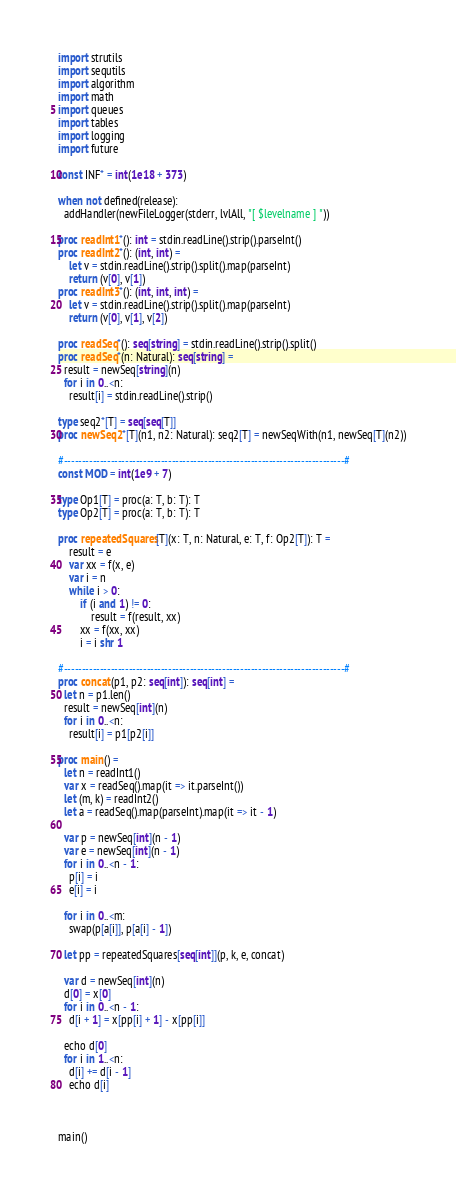Convert code to text. <code><loc_0><loc_0><loc_500><loc_500><_Nim_>import strutils
import sequtils
import algorithm
import math
import queues
import tables
import logging
import future

const INF* = int(1e18 + 373)

when not defined(release):
  addHandler(newFileLogger(stderr, lvlAll, "[ $levelname ] "))

proc readInt1*(): int = stdin.readLine().strip().parseInt()
proc readInt2*(): (int, int) =
    let v = stdin.readLine().strip().split().map(parseInt)
    return (v[0], v[1])
proc readInt3*(): (int, int, int) =
    let v = stdin.readLine().strip().split().map(parseInt)
    return (v[0], v[1], v[2])

proc readSeq*(): seq[string] = stdin.readLine().strip().split()
proc readSeq*(n: Natural): seq[string] =
  result = newSeq[string](n)
  for i in 0..<n:
    result[i] = stdin.readLine().strip()

type seq2*[T] = seq[seq[T]]
proc newSeq2*[T](n1, n2: Natural): seq2[T] = newSeqWith(n1, newSeq[T](n2))

#------------------------------------------------------------------------------#
const MOD = int(1e9 + 7)

type Op1[T] = proc(a: T, b: T): T
type Op2[T] = proc(a: T, b: T): T

proc repeatedSquares[T](x: T, n: Natural, e: T, f: Op2[T]): T =
    result = e
    var xx = f(x, e)
    var i = n
    while i > 0:
        if (i and 1) != 0:
            result = f(result, xx)
        xx = f(xx, xx)
        i = i shr 1

#------------------------------------------------------------------------------#
proc concat(p1, p2: seq[int]): seq[int] =
  let n = p1.len()
  result = newSeq[int](n)
  for i in 0..<n:
    result[i] = p1[p2[i]]

proc main() =
  let n = readInt1()
  var x = readSeq().map(it => it.parseInt())
  let (m, k) = readInt2()
  let a = readSeq().map(parseInt).map(it => it - 1)

  var p = newSeq[int](n - 1)
  var e = newSeq[int](n - 1)
  for i in 0..<n - 1:
    p[i] = i
    e[i] = i

  for i in 0..<m:
    swap(p[a[i]], p[a[i] - 1])

  let pp = repeatedSquares[seq[int]](p, k, e, concat)

  var d = newSeq[int](n)
  d[0] = x[0]
  for i in 0..<n - 1:
    d[i + 1] = x[pp[i] + 1] - x[pp[i]]

  echo d[0]
  for i in 1..<n:
    d[i] += d[i - 1]
    echo d[i]



main()

</code> 